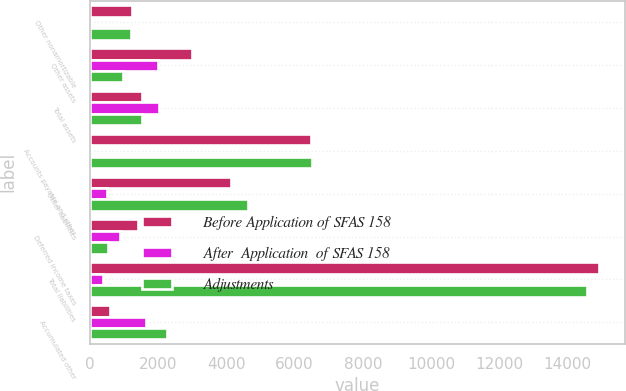Convert chart. <chart><loc_0><loc_0><loc_500><loc_500><stacked_bar_chart><ecel><fcel>Other nonamortizable<fcel>Other assets<fcel>Total assets<fcel>Accounts payable and other<fcel>Other liabilities<fcel>Deferred income taxes<fcel>Total liabilities<fcel>Accumulated other<nl><fcel>Before Application of SFAS 158<fcel>1229<fcel>2979<fcel>1531<fcel>6475<fcel>4127<fcel>1419<fcel>14935<fcel>603<nl><fcel>After  Application  of SFAS 158<fcel>17<fcel>1999<fcel>2016<fcel>21<fcel>497<fcel>891<fcel>373<fcel>1643<nl><fcel>Adjustments<fcel>1212<fcel>980<fcel>1531<fcel>6496<fcel>4624<fcel>528<fcel>14562<fcel>2246<nl></chart> 